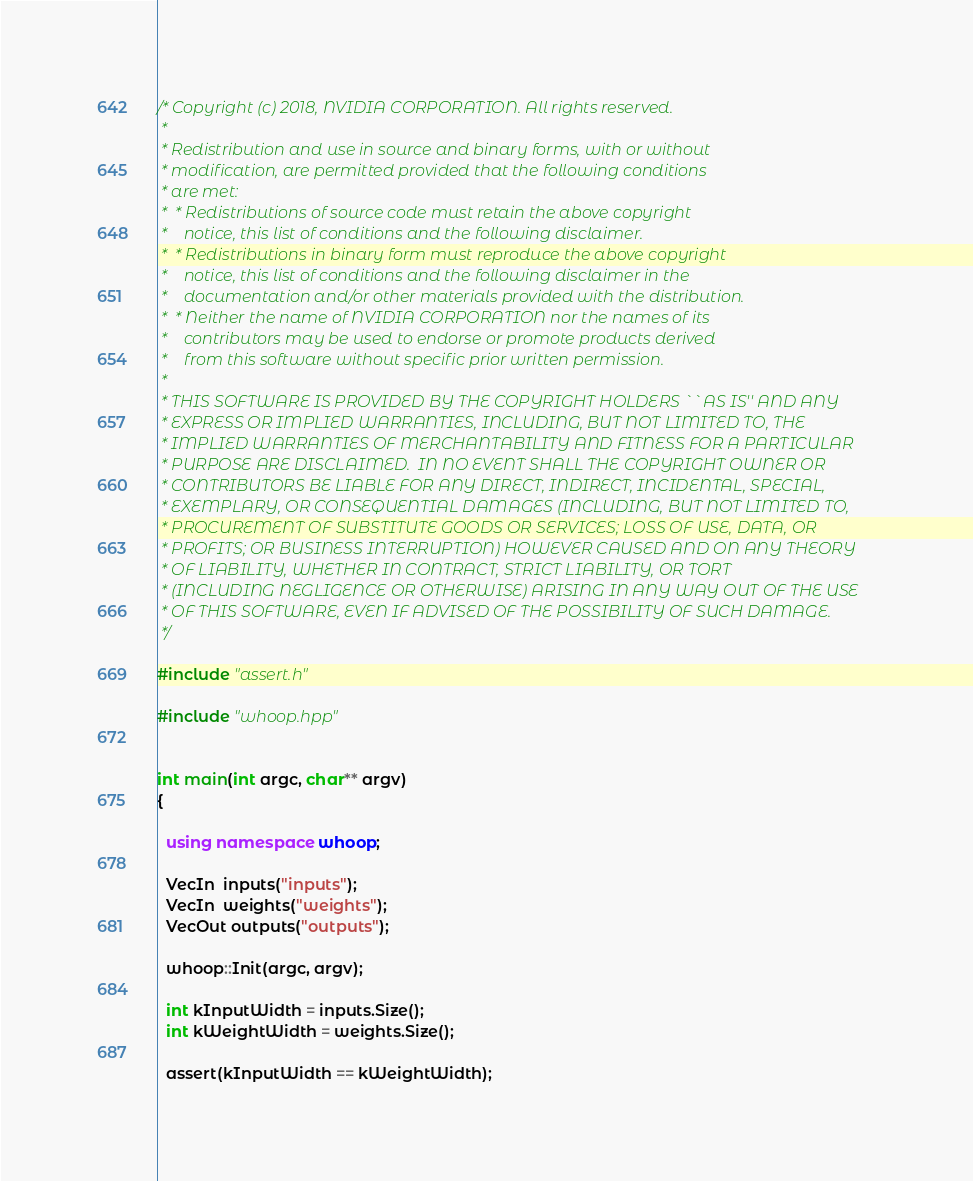Convert code to text. <code><loc_0><loc_0><loc_500><loc_500><_C++_>/* Copyright (c) 2018, NVIDIA CORPORATION. All rights reserved.
 *
 * Redistribution and use in source and binary forms, with or without
 * modification, are permitted provided that the following conditions
 * are met:
 *  * Redistributions of source code must retain the above copyright
 *    notice, this list of conditions and the following disclaimer.
 *  * Redistributions in binary form must reproduce the above copyright
 *    notice, this list of conditions and the following disclaimer in the
 *    documentation and/or other materials provided with the distribution.
 *  * Neither the name of NVIDIA CORPORATION nor the names of its
 *    contributors may be used to endorse or promote products derived
 *    from this software without specific prior written permission.
 *
 * THIS SOFTWARE IS PROVIDED BY THE COPYRIGHT HOLDERS ``AS IS'' AND ANY
 * EXPRESS OR IMPLIED WARRANTIES, INCLUDING, BUT NOT LIMITED TO, THE
 * IMPLIED WARRANTIES OF MERCHANTABILITY AND FITNESS FOR A PARTICULAR
 * PURPOSE ARE DISCLAIMED.  IN NO EVENT SHALL THE COPYRIGHT OWNER OR
 * CONTRIBUTORS BE LIABLE FOR ANY DIRECT, INDIRECT, INCIDENTAL, SPECIAL,
 * EXEMPLARY, OR CONSEQUENTIAL DAMAGES (INCLUDING, BUT NOT LIMITED TO,
 * PROCUREMENT OF SUBSTITUTE GOODS OR SERVICES; LOSS OF USE, DATA, OR
 * PROFITS; OR BUSINESS INTERRUPTION) HOWEVER CAUSED AND ON ANY THEORY
 * OF LIABILITY, WHETHER IN CONTRACT, STRICT LIABILITY, OR TORT
 * (INCLUDING NEGLIGENCE OR OTHERWISE) ARISING IN ANY WAY OUT OF THE USE
 * OF THIS SOFTWARE, EVEN IF ADVISED OF THE POSSIBILITY OF SUCH DAMAGE.
 */

#include "assert.h"

#include "whoop.hpp"


int main(int argc, char** argv)
{

  using namespace whoop;
  
  VecIn  inputs("inputs");
  VecIn  weights("weights");
  VecOut outputs("outputs");

  whoop::Init(argc, argv);

  int kInputWidth = inputs.Size();
  int kWeightWidth = weights.Size();

  assert(kInputWidth == kWeightWidth);
</code> 